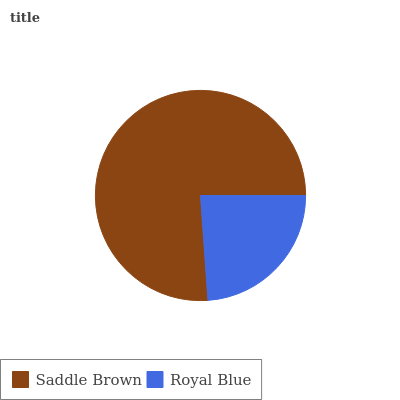Is Royal Blue the minimum?
Answer yes or no. Yes. Is Saddle Brown the maximum?
Answer yes or no. Yes. Is Royal Blue the maximum?
Answer yes or no. No. Is Saddle Brown greater than Royal Blue?
Answer yes or no. Yes. Is Royal Blue less than Saddle Brown?
Answer yes or no. Yes. Is Royal Blue greater than Saddle Brown?
Answer yes or no. No. Is Saddle Brown less than Royal Blue?
Answer yes or no. No. Is Saddle Brown the high median?
Answer yes or no. Yes. Is Royal Blue the low median?
Answer yes or no. Yes. Is Royal Blue the high median?
Answer yes or no. No. Is Saddle Brown the low median?
Answer yes or no. No. 